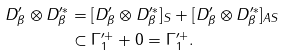Convert formula to latex. <formula><loc_0><loc_0><loc_500><loc_500>D ^ { \prime } _ { \beta } \otimes D ^ { \prime \ast } _ { \beta } & = [ D ^ { \prime } _ { \beta } \otimes D ^ { \prime \ast } _ { \beta } ] _ { S } + [ D ^ { \prime } _ { \beta } \otimes D ^ { \prime \ast } _ { \beta } ] _ { A S } \\ & \subset \Gamma ^ { \prime + } _ { 1 } + 0 = \Gamma ^ { \prime + } _ { 1 } .</formula> 